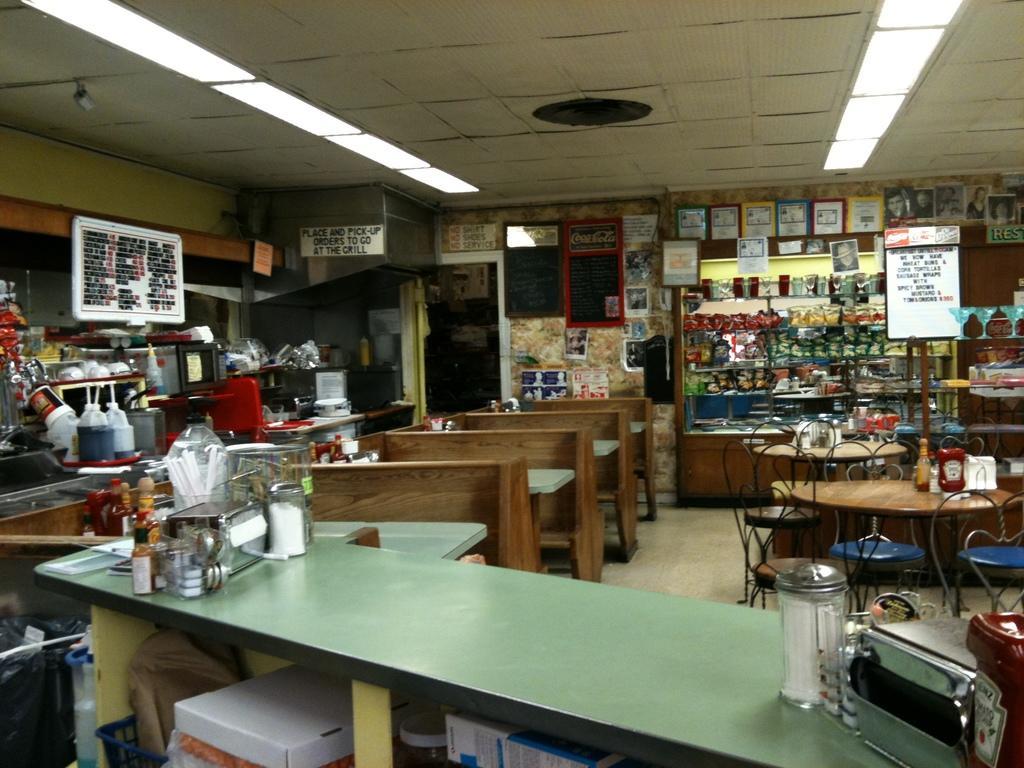How would you summarize this image in a sentence or two? In this image, we can see wooden objects, tables, chairs and a few objects. Here we can see few machines. Background we can see wall, boards, posters, door, floor. Top of the image, we can see the ceilings and lights. 